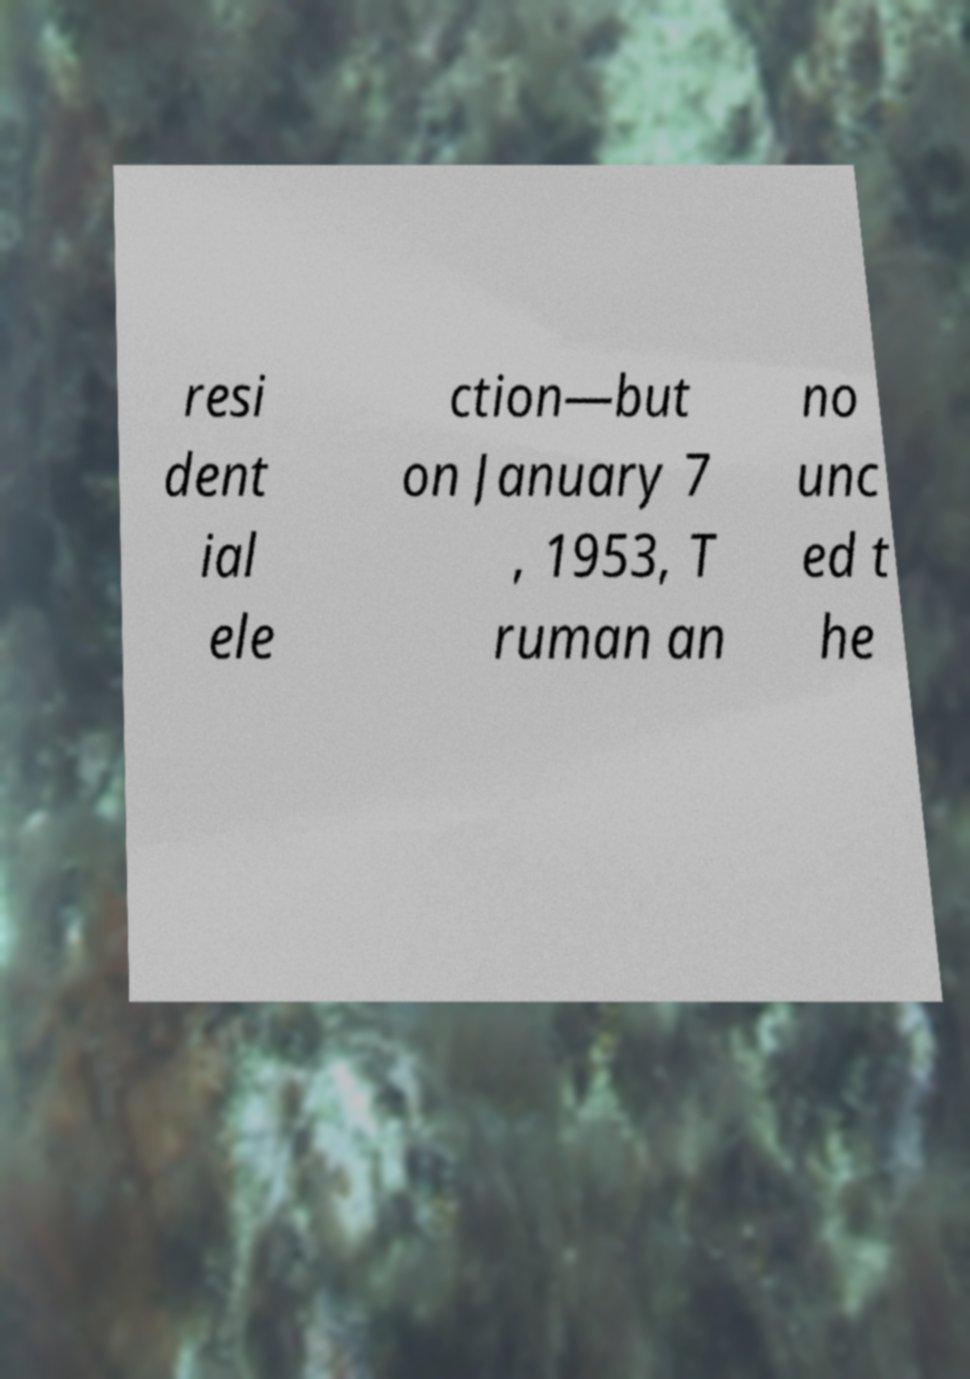Please read and relay the text visible in this image. What does it say? resi dent ial ele ction—but on January 7 , 1953, T ruman an no unc ed t he 